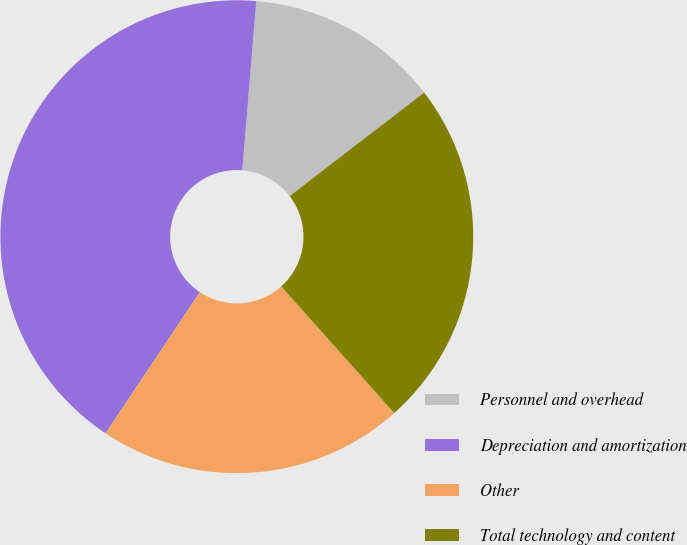Convert chart to OTSL. <chart><loc_0><loc_0><loc_500><loc_500><pie_chart><fcel>Personnel and overhead<fcel>Depreciation and amortization<fcel>Other<fcel>Total technology and content<nl><fcel>13.25%<fcel>41.94%<fcel>20.97%<fcel>23.84%<nl></chart> 